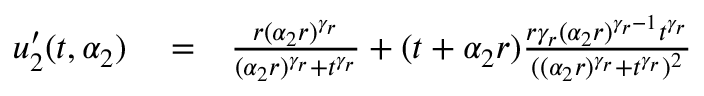<formula> <loc_0><loc_0><loc_500><loc_500>\begin{array} { r l r } { u _ { 2 } ^ { \prime } ( t , \alpha _ { 2 } ) } & = } & { \frac { r ( \alpha _ { 2 } r ) ^ { \gamma _ { r } } } { ( \alpha _ { 2 } r ) ^ { \gamma _ { r } } + t ^ { \gamma _ { r } } } + ( t + \alpha _ { 2 } r ) \frac { r \gamma _ { r } ( \alpha _ { 2 } r ) ^ { \gamma _ { r } - 1 } t ^ { \gamma _ { r } } } { ( ( \alpha _ { 2 } r ) ^ { \gamma _ { r } } + t ^ { \gamma _ { r } } ) ^ { 2 } } } \end{array}</formula> 